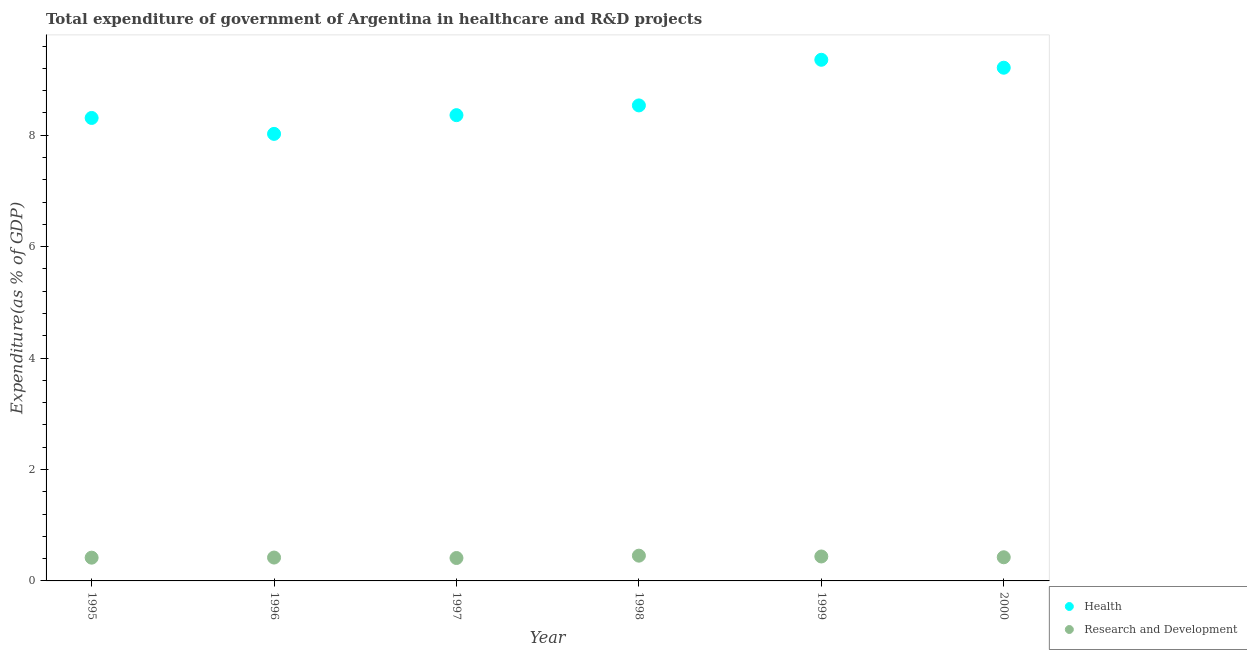Is the number of dotlines equal to the number of legend labels?
Keep it short and to the point. Yes. What is the expenditure in r&d in 1995?
Offer a very short reply. 0.42. Across all years, what is the maximum expenditure in r&d?
Ensure brevity in your answer.  0.45. Across all years, what is the minimum expenditure in r&d?
Make the answer very short. 0.41. What is the total expenditure in healthcare in the graph?
Ensure brevity in your answer.  51.8. What is the difference between the expenditure in healthcare in 1995 and that in 1996?
Provide a short and direct response. 0.29. What is the difference between the expenditure in healthcare in 2000 and the expenditure in r&d in 1998?
Offer a terse response. 8.76. What is the average expenditure in healthcare per year?
Your answer should be compact. 8.63. In the year 1996, what is the difference between the expenditure in healthcare and expenditure in r&d?
Keep it short and to the point. 7.61. In how many years, is the expenditure in healthcare greater than 2 %?
Keep it short and to the point. 6. What is the ratio of the expenditure in healthcare in 1995 to that in 1996?
Offer a terse response. 1.04. What is the difference between the highest and the second highest expenditure in healthcare?
Keep it short and to the point. 0.14. What is the difference between the highest and the lowest expenditure in r&d?
Your answer should be very brief. 0.04. In how many years, is the expenditure in healthcare greater than the average expenditure in healthcare taken over all years?
Keep it short and to the point. 2. Does the expenditure in healthcare monotonically increase over the years?
Offer a terse response. No. Is the expenditure in r&d strictly greater than the expenditure in healthcare over the years?
Your answer should be very brief. No. Is the expenditure in healthcare strictly less than the expenditure in r&d over the years?
Provide a succinct answer. No. How many dotlines are there?
Offer a terse response. 2. What is the difference between two consecutive major ticks on the Y-axis?
Your response must be concise. 2. Are the values on the major ticks of Y-axis written in scientific E-notation?
Offer a terse response. No. Does the graph contain any zero values?
Your answer should be compact. No. Where does the legend appear in the graph?
Your answer should be very brief. Bottom right. How many legend labels are there?
Offer a very short reply. 2. What is the title of the graph?
Keep it short and to the point. Total expenditure of government of Argentina in healthcare and R&D projects. What is the label or title of the X-axis?
Offer a very short reply. Year. What is the label or title of the Y-axis?
Ensure brevity in your answer.  Expenditure(as % of GDP). What is the Expenditure(as % of GDP) in Health in 1995?
Your response must be concise. 8.31. What is the Expenditure(as % of GDP) in Research and Development in 1995?
Provide a short and direct response. 0.42. What is the Expenditure(as % of GDP) in Health in 1996?
Offer a terse response. 8.02. What is the Expenditure(as % of GDP) in Research and Development in 1996?
Your response must be concise. 0.42. What is the Expenditure(as % of GDP) in Health in 1997?
Make the answer very short. 8.36. What is the Expenditure(as % of GDP) in Research and Development in 1997?
Your response must be concise. 0.41. What is the Expenditure(as % of GDP) in Health in 1998?
Ensure brevity in your answer.  8.54. What is the Expenditure(as % of GDP) of Research and Development in 1998?
Ensure brevity in your answer.  0.45. What is the Expenditure(as % of GDP) of Health in 1999?
Offer a terse response. 9.36. What is the Expenditure(as % of GDP) in Research and Development in 1999?
Your answer should be very brief. 0.44. What is the Expenditure(as % of GDP) in Health in 2000?
Keep it short and to the point. 9.21. What is the Expenditure(as % of GDP) of Research and Development in 2000?
Give a very brief answer. 0.42. Across all years, what is the maximum Expenditure(as % of GDP) in Health?
Offer a terse response. 9.36. Across all years, what is the maximum Expenditure(as % of GDP) of Research and Development?
Provide a short and direct response. 0.45. Across all years, what is the minimum Expenditure(as % of GDP) in Health?
Give a very brief answer. 8.02. Across all years, what is the minimum Expenditure(as % of GDP) in Research and Development?
Ensure brevity in your answer.  0.41. What is the total Expenditure(as % of GDP) in Health in the graph?
Offer a very short reply. 51.8. What is the total Expenditure(as % of GDP) in Research and Development in the graph?
Ensure brevity in your answer.  2.57. What is the difference between the Expenditure(as % of GDP) of Health in 1995 and that in 1996?
Make the answer very short. 0.29. What is the difference between the Expenditure(as % of GDP) of Research and Development in 1995 and that in 1996?
Provide a short and direct response. -0. What is the difference between the Expenditure(as % of GDP) of Health in 1995 and that in 1997?
Offer a very short reply. -0.05. What is the difference between the Expenditure(as % of GDP) in Research and Development in 1995 and that in 1997?
Offer a very short reply. 0.01. What is the difference between the Expenditure(as % of GDP) in Health in 1995 and that in 1998?
Give a very brief answer. -0.22. What is the difference between the Expenditure(as % of GDP) in Research and Development in 1995 and that in 1998?
Your answer should be compact. -0.04. What is the difference between the Expenditure(as % of GDP) in Health in 1995 and that in 1999?
Your answer should be very brief. -1.04. What is the difference between the Expenditure(as % of GDP) in Research and Development in 1995 and that in 1999?
Keep it short and to the point. -0.02. What is the difference between the Expenditure(as % of GDP) of Health in 1995 and that in 2000?
Provide a short and direct response. -0.9. What is the difference between the Expenditure(as % of GDP) of Research and Development in 1995 and that in 2000?
Keep it short and to the point. -0.01. What is the difference between the Expenditure(as % of GDP) in Health in 1996 and that in 1997?
Make the answer very short. -0.34. What is the difference between the Expenditure(as % of GDP) of Research and Development in 1996 and that in 1997?
Provide a short and direct response. 0.01. What is the difference between the Expenditure(as % of GDP) in Health in 1996 and that in 1998?
Your answer should be compact. -0.51. What is the difference between the Expenditure(as % of GDP) of Research and Development in 1996 and that in 1998?
Your answer should be compact. -0.03. What is the difference between the Expenditure(as % of GDP) of Health in 1996 and that in 1999?
Ensure brevity in your answer.  -1.33. What is the difference between the Expenditure(as % of GDP) in Research and Development in 1996 and that in 1999?
Provide a short and direct response. -0.02. What is the difference between the Expenditure(as % of GDP) of Health in 1996 and that in 2000?
Keep it short and to the point. -1.19. What is the difference between the Expenditure(as % of GDP) in Research and Development in 1996 and that in 2000?
Keep it short and to the point. -0.01. What is the difference between the Expenditure(as % of GDP) of Health in 1997 and that in 1998?
Provide a short and direct response. -0.17. What is the difference between the Expenditure(as % of GDP) of Research and Development in 1997 and that in 1998?
Give a very brief answer. -0.04. What is the difference between the Expenditure(as % of GDP) of Health in 1997 and that in 1999?
Keep it short and to the point. -0.99. What is the difference between the Expenditure(as % of GDP) of Research and Development in 1997 and that in 1999?
Ensure brevity in your answer.  -0.03. What is the difference between the Expenditure(as % of GDP) in Health in 1997 and that in 2000?
Your response must be concise. -0.85. What is the difference between the Expenditure(as % of GDP) in Research and Development in 1997 and that in 2000?
Offer a terse response. -0.01. What is the difference between the Expenditure(as % of GDP) of Health in 1998 and that in 1999?
Give a very brief answer. -0.82. What is the difference between the Expenditure(as % of GDP) in Research and Development in 1998 and that in 1999?
Your answer should be very brief. 0.01. What is the difference between the Expenditure(as % of GDP) of Health in 1998 and that in 2000?
Provide a succinct answer. -0.68. What is the difference between the Expenditure(as % of GDP) of Research and Development in 1998 and that in 2000?
Your answer should be very brief. 0.03. What is the difference between the Expenditure(as % of GDP) in Health in 1999 and that in 2000?
Keep it short and to the point. 0.14. What is the difference between the Expenditure(as % of GDP) in Research and Development in 1999 and that in 2000?
Your answer should be very brief. 0.01. What is the difference between the Expenditure(as % of GDP) of Health in 1995 and the Expenditure(as % of GDP) of Research and Development in 1996?
Keep it short and to the point. 7.89. What is the difference between the Expenditure(as % of GDP) in Health in 1995 and the Expenditure(as % of GDP) in Research and Development in 1997?
Make the answer very short. 7.9. What is the difference between the Expenditure(as % of GDP) in Health in 1995 and the Expenditure(as % of GDP) in Research and Development in 1998?
Provide a succinct answer. 7.86. What is the difference between the Expenditure(as % of GDP) of Health in 1995 and the Expenditure(as % of GDP) of Research and Development in 1999?
Your response must be concise. 7.87. What is the difference between the Expenditure(as % of GDP) in Health in 1995 and the Expenditure(as % of GDP) in Research and Development in 2000?
Offer a very short reply. 7.89. What is the difference between the Expenditure(as % of GDP) in Health in 1996 and the Expenditure(as % of GDP) in Research and Development in 1997?
Provide a succinct answer. 7.61. What is the difference between the Expenditure(as % of GDP) in Health in 1996 and the Expenditure(as % of GDP) in Research and Development in 1998?
Your response must be concise. 7.57. What is the difference between the Expenditure(as % of GDP) of Health in 1996 and the Expenditure(as % of GDP) of Research and Development in 1999?
Your answer should be compact. 7.59. What is the difference between the Expenditure(as % of GDP) of Health in 1996 and the Expenditure(as % of GDP) of Research and Development in 2000?
Keep it short and to the point. 7.6. What is the difference between the Expenditure(as % of GDP) in Health in 1997 and the Expenditure(as % of GDP) in Research and Development in 1998?
Ensure brevity in your answer.  7.91. What is the difference between the Expenditure(as % of GDP) of Health in 1997 and the Expenditure(as % of GDP) of Research and Development in 1999?
Give a very brief answer. 7.92. What is the difference between the Expenditure(as % of GDP) of Health in 1997 and the Expenditure(as % of GDP) of Research and Development in 2000?
Your answer should be compact. 7.94. What is the difference between the Expenditure(as % of GDP) of Health in 1998 and the Expenditure(as % of GDP) of Research and Development in 1999?
Your response must be concise. 8.1. What is the difference between the Expenditure(as % of GDP) in Health in 1998 and the Expenditure(as % of GDP) in Research and Development in 2000?
Your answer should be compact. 8.11. What is the difference between the Expenditure(as % of GDP) in Health in 1999 and the Expenditure(as % of GDP) in Research and Development in 2000?
Offer a terse response. 8.93. What is the average Expenditure(as % of GDP) in Health per year?
Provide a succinct answer. 8.63. What is the average Expenditure(as % of GDP) in Research and Development per year?
Give a very brief answer. 0.43. In the year 1995, what is the difference between the Expenditure(as % of GDP) in Health and Expenditure(as % of GDP) in Research and Development?
Make the answer very short. 7.89. In the year 1996, what is the difference between the Expenditure(as % of GDP) of Health and Expenditure(as % of GDP) of Research and Development?
Make the answer very short. 7.61. In the year 1997, what is the difference between the Expenditure(as % of GDP) of Health and Expenditure(as % of GDP) of Research and Development?
Offer a very short reply. 7.95. In the year 1998, what is the difference between the Expenditure(as % of GDP) of Health and Expenditure(as % of GDP) of Research and Development?
Your answer should be compact. 8.08. In the year 1999, what is the difference between the Expenditure(as % of GDP) in Health and Expenditure(as % of GDP) in Research and Development?
Ensure brevity in your answer.  8.92. In the year 2000, what is the difference between the Expenditure(as % of GDP) in Health and Expenditure(as % of GDP) in Research and Development?
Offer a terse response. 8.79. What is the ratio of the Expenditure(as % of GDP) of Health in 1995 to that in 1996?
Provide a succinct answer. 1.04. What is the ratio of the Expenditure(as % of GDP) of Health in 1995 to that in 1997?
Give a very brief answer. 0.99. What is the ratio of the Expenditure(as % of GDP) of Research and Development in 1995 to that in 1997?
Provide a short and direct response. 1.01. What is the ratio of the Expenditure(as % of GDP) of Health in 1995 to that in 1998?
Make the answer very short. 0.97. What is the ratio of the Expenditure(as % of GDP) in Research and Development in 1995 to that in 1998?
Keep it short and to the point. 0.92. What is the ratio of the Expenditure(as % of GDP) of Health in 1995 to that in 1999?
Provide a succinct answer. 0.89. What is the ratio of the Expenditure(as % of GDP) in Research and Development in 1995 to that in 1999?
Keep it short and to the point. 0.95. What is the ratio of the Expenditure(as % of GDP) of Health in 1995 to that in 2000?
Keep it short and to the point. 0.9. What is the ratio of the Expenditure(as % of GDP) of Research and Development in 1995 to that in 2000?
Offer a terse response. 0.98. What is the ratio of the Expenditure(as % of GDP) in Health in 1996 to that in 1997?
Your response must be concise. 0.96. What is the ratio of the Expenditure(as % of GDP) in Research and Development in 1996 to that in 1997?
Offer a very short reply. 1.02. What is the ratio of the Expenditure(as % of GDP) in Health in 1996 to that in 1998?
Provide a succinct answer. 0.94. What is the ratio of the Expenditure(as % of GDP) of Research and Development in 1996 to that in 1998?
Offer a very short reply. 0.93. What is the ratio of the Expenditure(as % of GDP) in Health in 1996 to that in 1999?
Your answer should be compact. 0.86. What is the ratio of the Expenditure(as % of GDP) in Research and Development in 1996 to that in 1999?
Your response must be concise. 0.96. What is the ratio of the Expenditure(as % of GDP) in Health in 1996 to that in 2000?
Offer a terse response. 0.87. What is the ratio of the Expenditure(as % of GDP) of Research and Development in 1996 to that in 2000?
Offer a terse response. 0.99. What is the ratio of the Expenditure(as % of GDP) in Health in 1997 to that in 1998?
Provide a short and direct response. 0.98. What is the ratio of the Expenditure(as % of GDP) of Research and Development in 1997 to that in 1998?
Your response must be concise. 0.91. What is the ratio of the Expenditure(as % of GDP) of Health in 1997 to that in 1999?
Your response must be concise. 0.89. What is the ratio of the Expenditure(as % of GDP) of Research and Development in 1997 to that in 1999?
Your answer should be compact. 0.94. What is the ratio of the Expenditure(as % of GDP) of Health in 1997 to that in 2000?
Provide a succinct answer. 0.91. What is the ratio of the Expenditure(as % of GDP) in Research and Development in 1997 to that in 2000?
Ensure brevity in your answer.  0.97. What is the ratio of the Expenditure(as % of GDP) in Health in 1998 to that in 1999?
Offer a very short reply. 0.91. What is the ratio of the Expenditure(as % of GDP) of Research and Development in 1998 to that in 1999?
Provide a succinct answer. 1.03. What is the ratio of the Expenditure(as % of GDP) of Health in 1998 to that in 2000?
Your response must be concise. 0.93. What is the ratio of the Expenditure(as % of GDP) of Research and Development in 1998 to that in 2000?
Provide a succinct answer. 1.07. What is the ratio of the Expenditure(as % of GDP) of Health in 1999 to that in 2000?
Your answer should be compact. 1.02. What is the ratio of the Expenditure(as % of GDP) in Research and Development in 1999 to that in 2000?
Your response must be concise. 1.03. What is the difference between the highest and the second highest Expenditure(as % of GDP) of Health?
Your answer should be compact. 0.14. What is the difference between the highest and the second highest Expenditure(as % of GDP) of Research and Development?
Provide a succinct answer. 0.01. What is the difference between the highest and the lowest Expenditure(as % of GDP) of Health?
Provide a short and direct response. 1.33. What is the difference between the highest and the lowest Expenditure(as % of GDP) in Research and Development?
Ensure brevity in your answer.  0.04. 